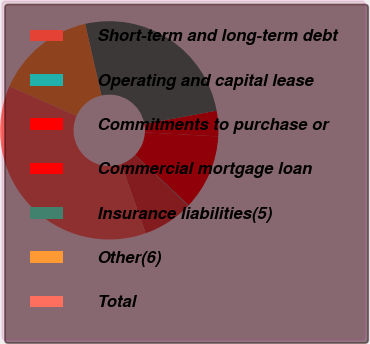Convert chart to OTSL. <chart><loc_0><loc_0><loc_500><loc_500><pie_chart><fcel>Short-term and long-term debt<fcel>Operating and capital lease<fcel>Commitments to purchase or<fcel>Commercial mortgage loan<fcel>Insurance liabilities(5)<fcel>Other(6)<fcel>Total<nl><fcel>7.47%<fcel>0.08%<fcel>11.16%<fcel>3.77%<fcel>25.66%<fcel>14.85%<fcel>37.01%<nl></chart> 